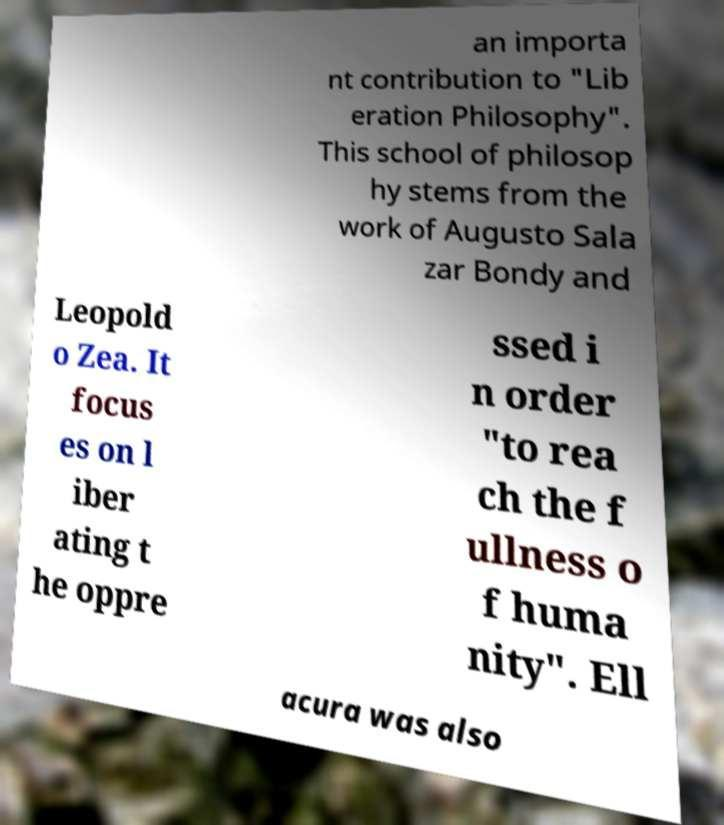Can you read and provide the text displayed in the image?This photo seems to have some interesting text. Can you extract and type it out for me? an importa nt contribution to "Lib eration Philosophy". This school of philosop hy stems from the work of Augusto Sala zar Bondy and Leopold o Zea. It focus es on l iber ating t he oppre ssed i n order "to rea ch the f ullness o f huma nity". Ell acura was also 